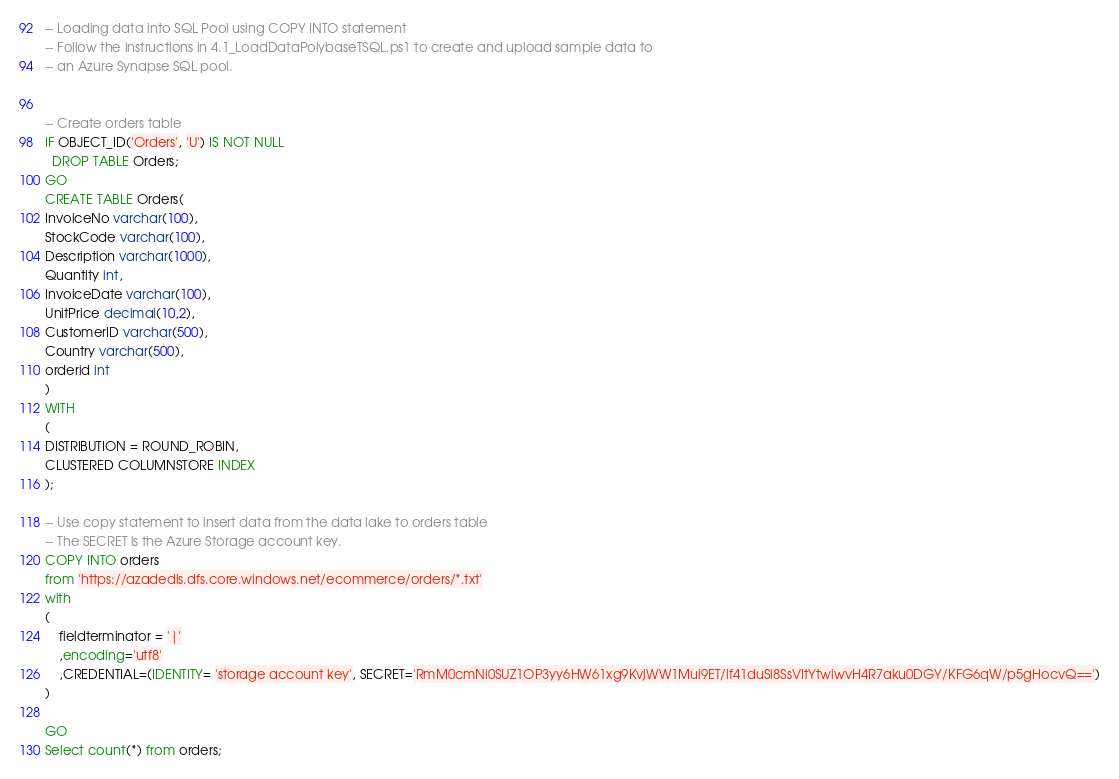<code> <loc_0><loc_0><loc_500><loc_500><_SQL_>-- Loading data into SQL Pool using COPY INTO statement
-- Follow the instructions in 4.1_LoadDataPolybaseTSQL.ps1 to create and upload sample data to 
-- an Azure Synapse SQL pool. 


-- Create orders table
IF OBJECT_ID('Orders', 'U') IS NOT NULL 
  DROP TABLE Orders; 
GO
CREATE TABLE Orders(
InvoiceNo varchar(100),
StockCode varchar(100),
Description varchar(1000),
Quantity int,
InvoiceDate varchar(100),
UnitPrice decimal(10,2),
CustomerID varchar(500),
Country varchar(500),
orderid int
)
WITH
(
DISTRIBUTION = ROUND_ROBIN,
CLUSTERED COLUMNSTORE INDEX
);

-- Use copy statement to insert data from the data lake to orders table
-- The SECRET is the Azure Storage account key.
COPY INTO orders 
from 'https://azadedls.dfs.core.windows.net/ecommerce/orders/*.txt'
with 
(
	fieldterminator = '|'
	,encoding='utf8'
	,CREDENTIAL=(IDENTITY= 'storage account key', SECRET='RmM0cmNi0SUZ1OP3yy6HW61xg9KvjWW1Mui9ET/lf41duSi8SsVItYtwiwvH4R7aku0DGY/KFG6qW/p5gHocvQ==')
)

GO
Select count(*) from orders;</code> 